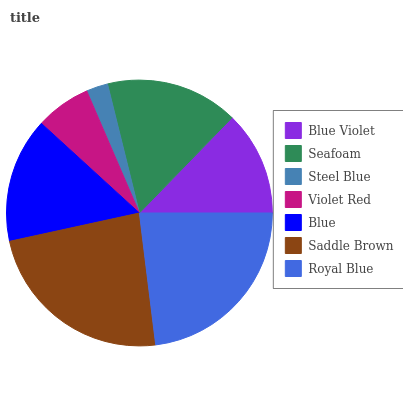Is Steel Blue the minimum?
Answer yes or no. Yes. Is Saddle Brown the maximum?
Answer yes or no. Yes. Is Seafoam the minimum?
Answer yes or no. No. Is Seafoam the maximum?
Answer yes or no. No. Is Seafoam greater than Blue Violet?
Answer yes or no. Yes. Is Blue Violet less than Seafoam?
Answer yes or no. Yes. Is Blue Violet greater than Seafoam?
Answer yes or no. No. Is Seafoam less than Blue Violet?
Answer yes or no. No. Is Blue the high median?
Answer yes or no. Yes. Is Blue the low median?
Answer yes or no. Yes. Is Violet Red the high median?
Answer yes or no. No. Is Saddle Brown the low median?
Answer yes or no. No. 